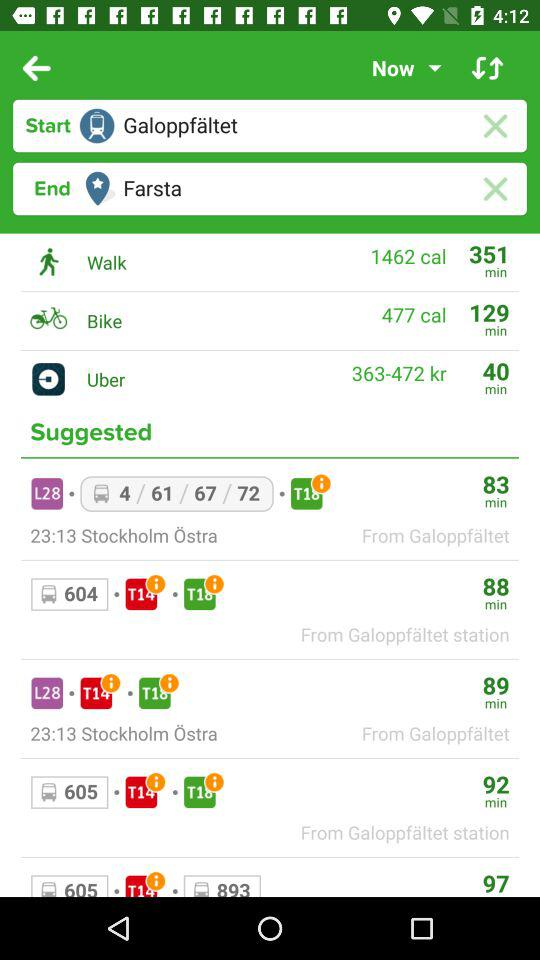What is the final destination? The final destination is Farsta. 